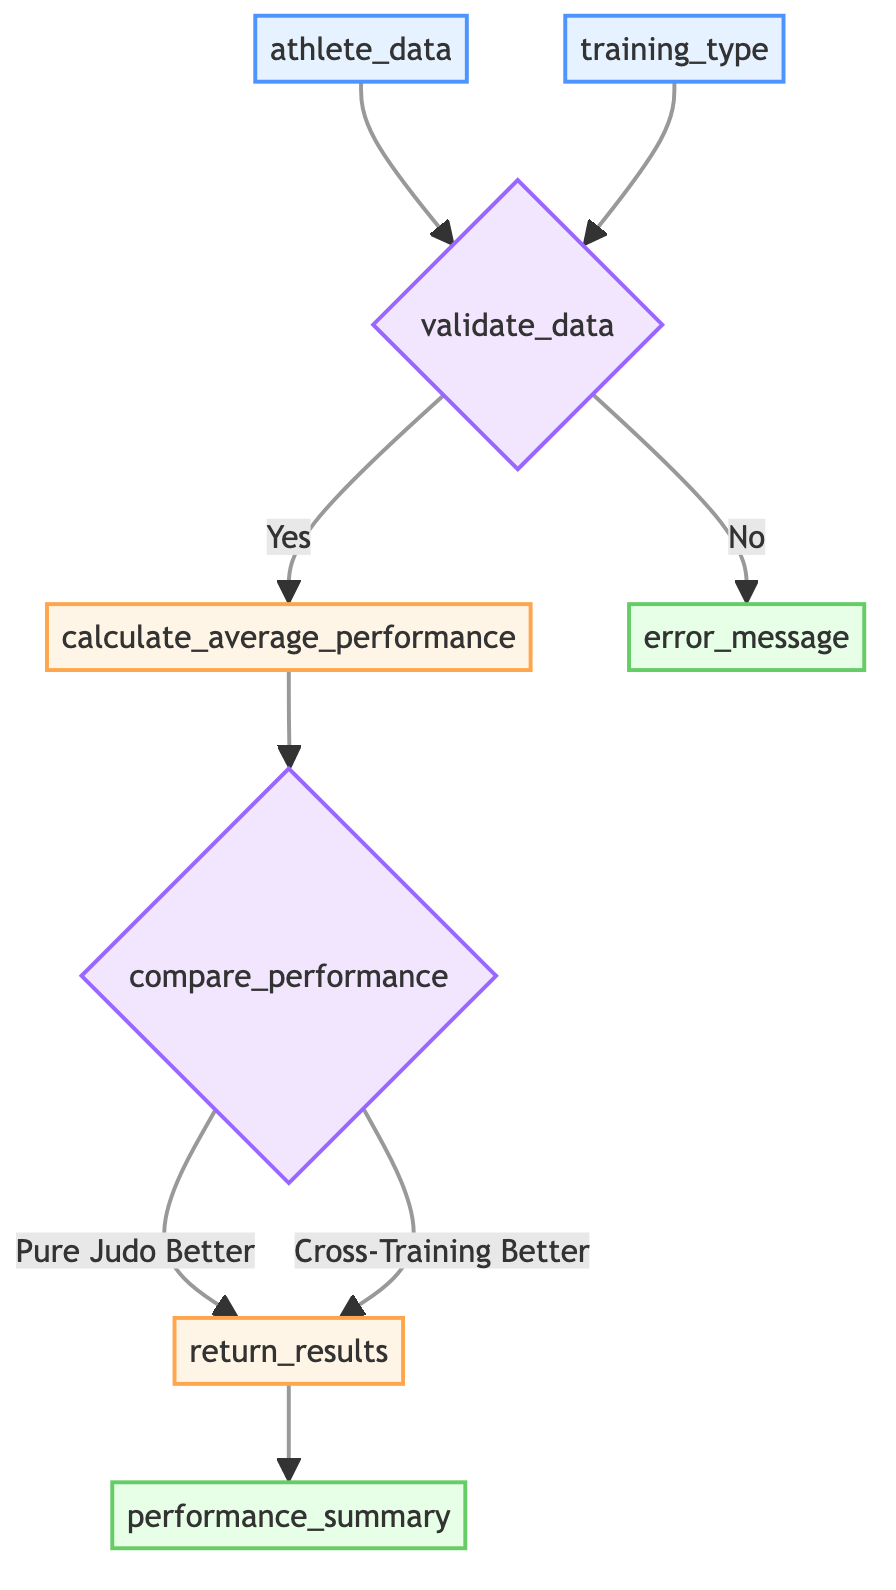What are the inputs to the function? The inputs to the function are 'athlete_data', which is a list containing individual performance metrics of judo athletes, and 'training_type', which specifies the type of training methods to compare: either 'pure_judo' or 'cross_training'.
Answer: athlete_data, training_type What happens if data validation fails? If the data validation fails, the flowchart directs to the 'error_message' node, indicating that an error message will be returned.
Answer: return_error_message What are the two pathways after the comparison of performance? After comparing performance, there are two pathways based on the outcome: one for 'pure_judo_better' and another for 'cross_training_better'.
Answer: pure_judo_better, cross_training_better How many decision points are there in the diagram? The diagram contains two decision points: one for 'validate_data' and another for 'compare_performance'.
Answer: 2 What is the output of the function? The primary output of the function is 'performance_summary', which provides detailed results of the performance comparison between pure judo training and cross-training.
Answer: performance_summary Describe the process that occurs after data validation is confirmed. Once data validation is confirmed (the decision is 'Yes'), the process proceeds to calculate average performance metrics, followed by comparing these performances before ultimately returning results.
Answer: calculate_average_performance, compare_performance, return_results What type of process is involved in calculating average performance? The calculation of average performance is identified as a process in the diagram, specifically a processing step that requires data input.
Answer: process What determines the path taken from the 'compare_performance' decision node? The path taken from the 'compare_performance' decision node is determined based on whether pure judo training metrics are better than those from cross-training.
Answer: average performance comparison 